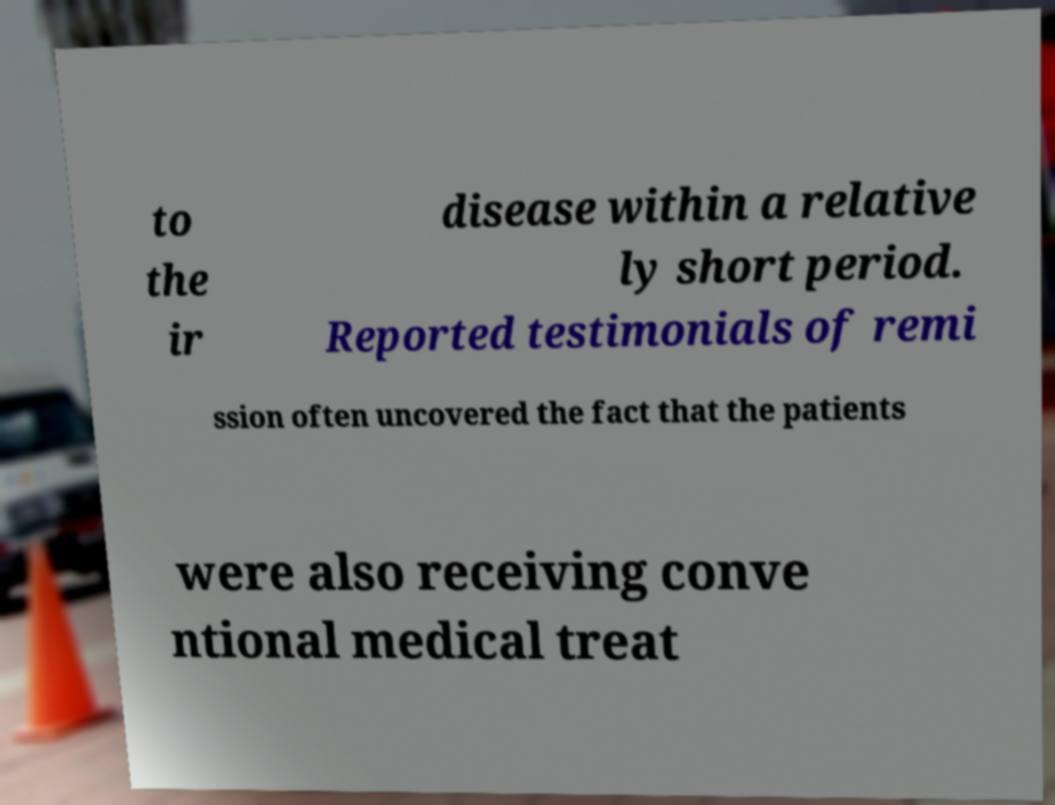Could you assist in decoding the text presented in this image and type it out clearly? to the ir disease within a relative ly short period. Reported testimonials of remi ssion often uncovered the fact that the patients were also receiving conve ntional medical treat 